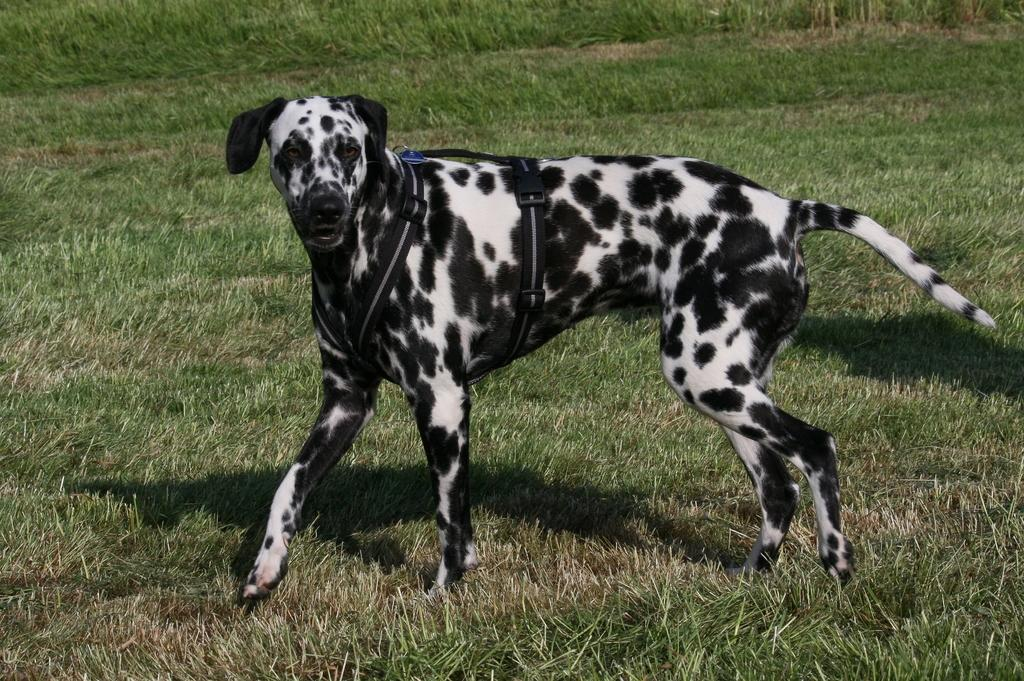What is the surface that the dog is standing on in the image? There is an open glass ground in the image. What type of animal is standing on the glass ground? A dog is standing on the glass ground. What is the color of the dog? The dog's color is black and white. Is there any accessory or item around the dog's body? Yes, there is a belt around the dog's body. What type of toys can be seen in the image? There are no toys present in the image. Is there a horse in the image? No, there is no horse in the image; it features a dog standing on a glass ground. 